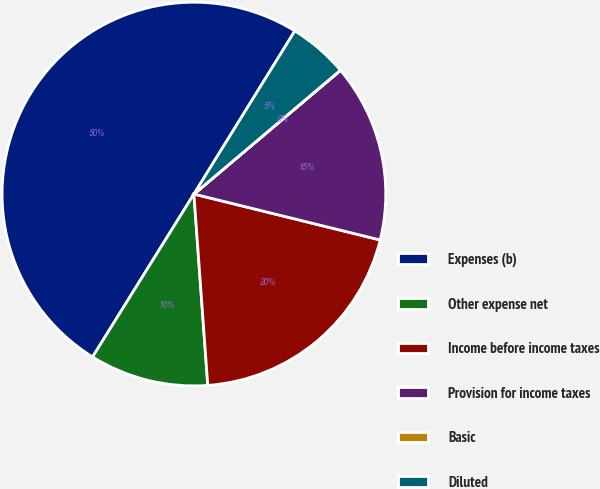Convert chart to OTSL. <chart><loc_0><loc_0><loc_500><loc_500><pie_chart><fcel>Expenses (b)<fcel>Other expense net<fcel>Income before income taxes<fcel>Provision for income taxes<fcel>Basic<fcel>Diluted<nl><fcel>49.96%<fcel>10.01%<fcel>20.0%<fcel>15.0%<fcel>0.02%<fcel>5.01%<nl></chart> 